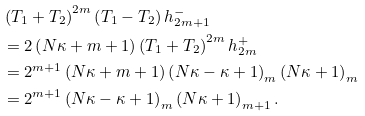Convert formula to latex. <formula><loc_0><loc_0><loc_500><loc_500>& \left ( T _ { 1 } + T _ { 2 } \right ) ^ { 2 m } \left ( T _ { 1 } - T _ { 2 } \right ) h _ { 2 m + 1 } ^ { - } \\ & = 2 \left ( N \kappa + m + 1 \right ) \left ( T _ { 1 } + T _ { 2 } \right ) ^ { 2 m } h _ { 2 m } ^ { + } \\ & = 2 ^ { m + 1 } \left ( N \kappa + m + 1 \right ) \left ( N \kappa - \kappa + 1 \right ) _ { m } \left ( N \kappa + 1 \right ) _ { m } \\ & = 2 ^ { m + 1 } \left ( N \kappa - \kappa + 1 \right ) _ { m } \left ( N \kappa + 1 \right ) _ { m + 1 } .</formula> 